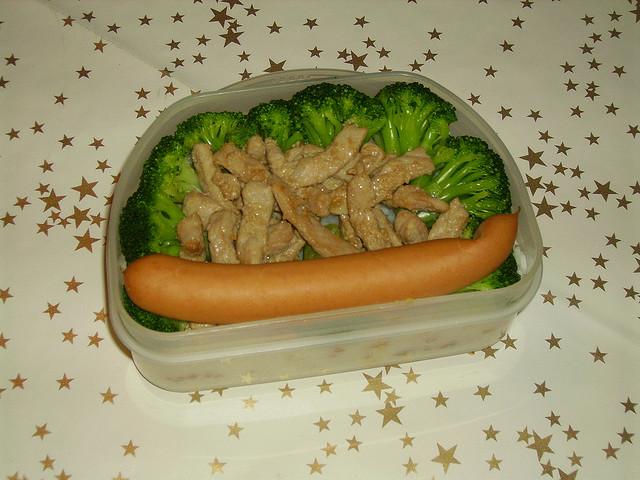What color is the container?
Write a very short answer. Clear. What color are the stars?
Quick response, please. Gold. Is there meat in the box?
Give a very brief answer. Yes. What is the green food?
Quick response, please. Broccoli. Would the food in the picture be consider healthier than McDonald's Chicken Nuggets?
Keep it brief. Yes. Is the hot dog yummy?
Short answer required. No. 